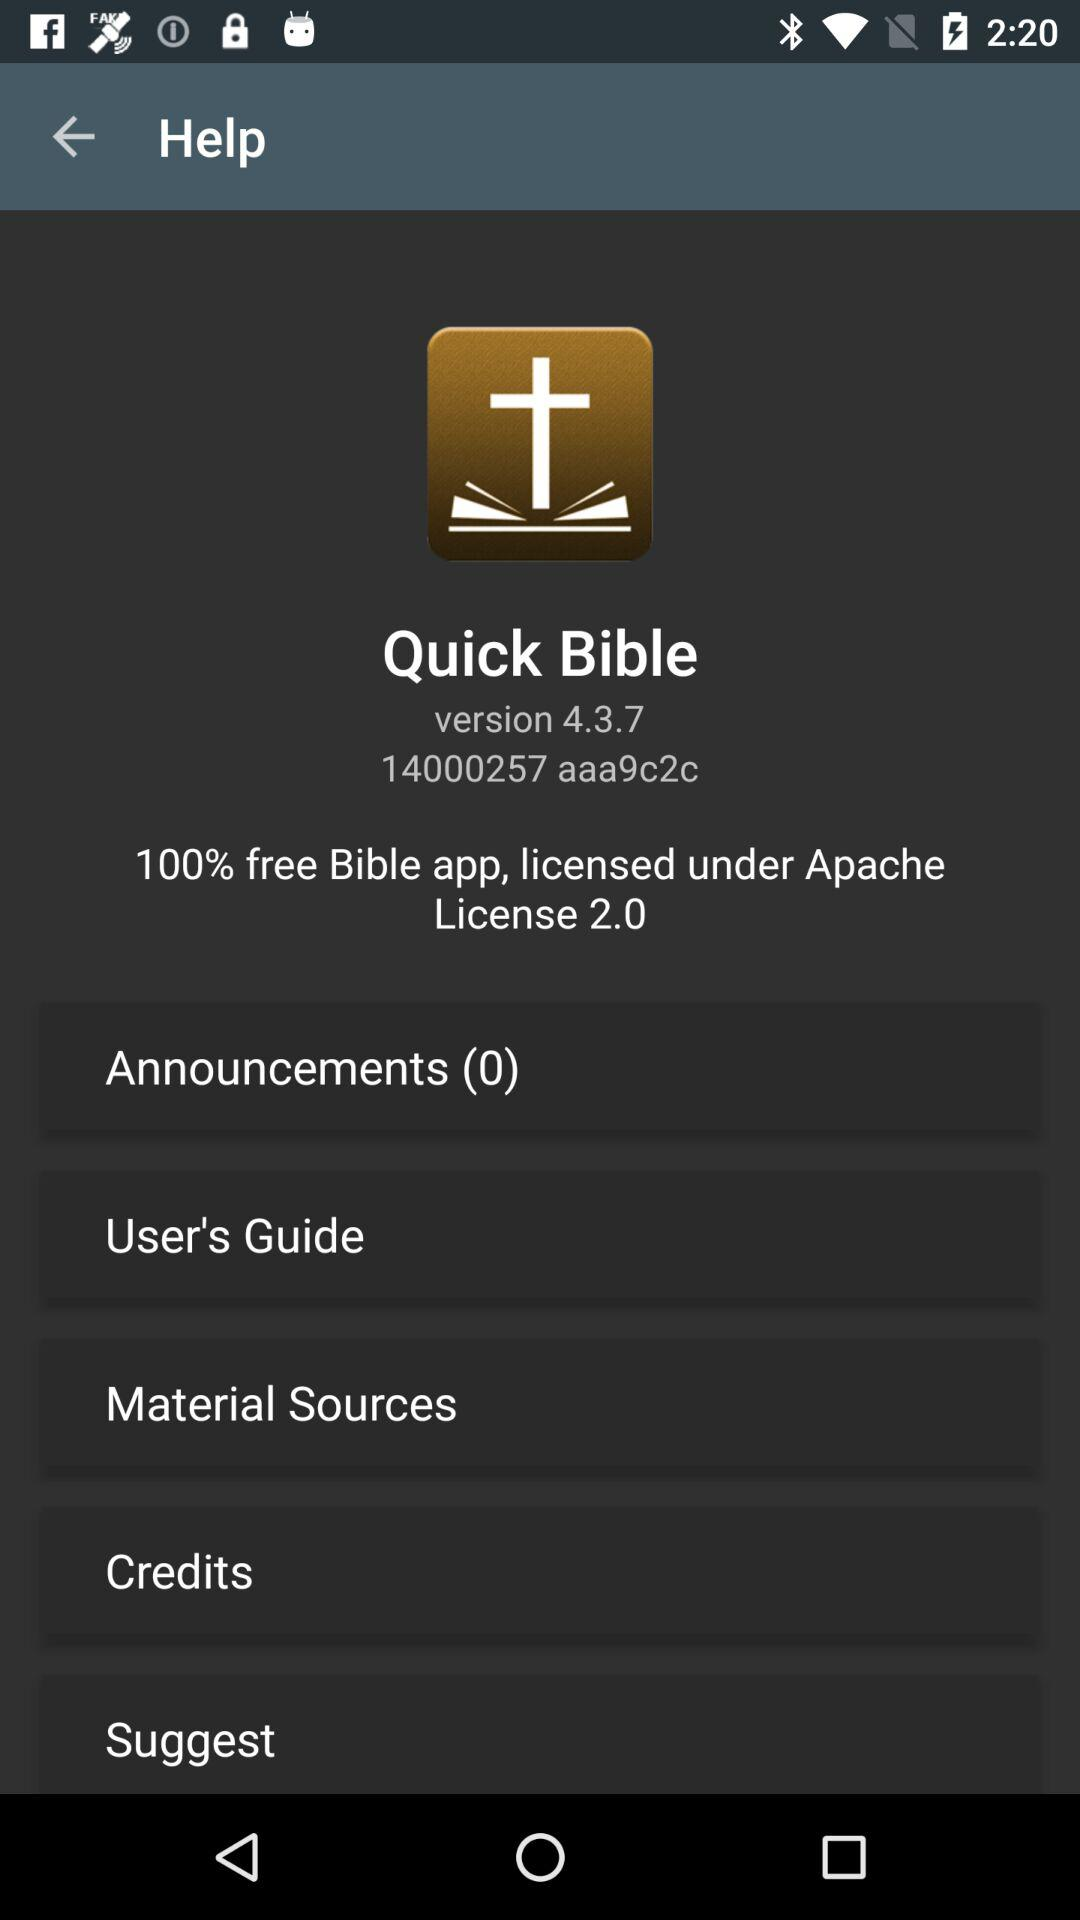What is the name of the application? The name of the application is "Quick Bible". 